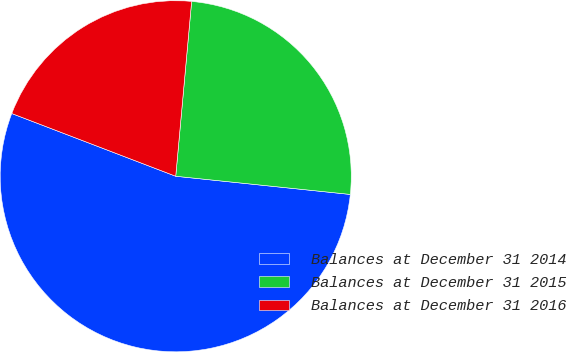<chart> <loc_0><loc_0><loc_500><loc_500><pie_chart><fcel>Balances at December 31 2014<fcel>Balances at December 31 2015<fcel>Balances at December 31 2016<nl><fcel>54.17%<fcel>25.21%<fcel>20.63%<nl></chart> 